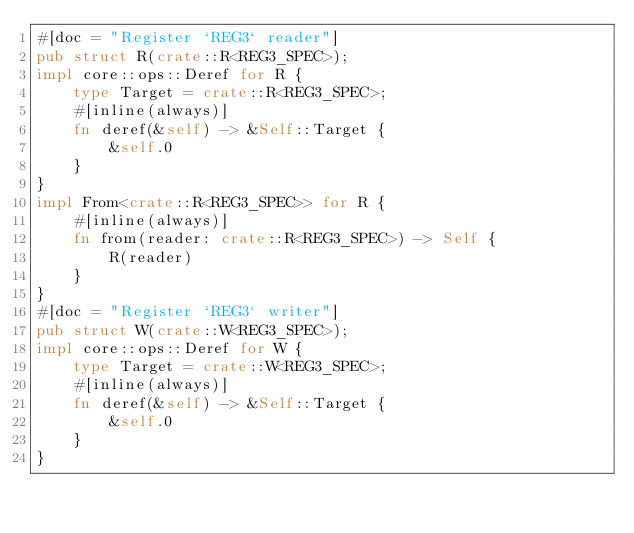Convert code to text. <code><loc_0><loc_0><loc_500><loc_500><_Rust_>#[doc = "Register `REG3` reader"]
pub struct R(crate::R<REG3_SPEC>);
impl core::ops::Deref for R {
    type Target = crate::R<REG3_SPEC>;
    #[inline(always)]
    fn deref(&self) -> &Self::Target {
        &self.0
    }
}
impl From<crate::R<REG3_SPEC>> for R {
    #[inline(always)]
    fn from(reader: crate::R<REG3_SPEC>) -> Self {
        R(reader)
    }
}
#[doc = "Register `REG3` writer"]
pub struct W(crate::W<REG3_SPEC>);
impl core::ops::Deref for W {
    type Target = crate::W<REG3_SPEC>;
    #[inline(always)]
    fn deref(&self) -> &Self::Target {
        &self.0
    }
}</code> 